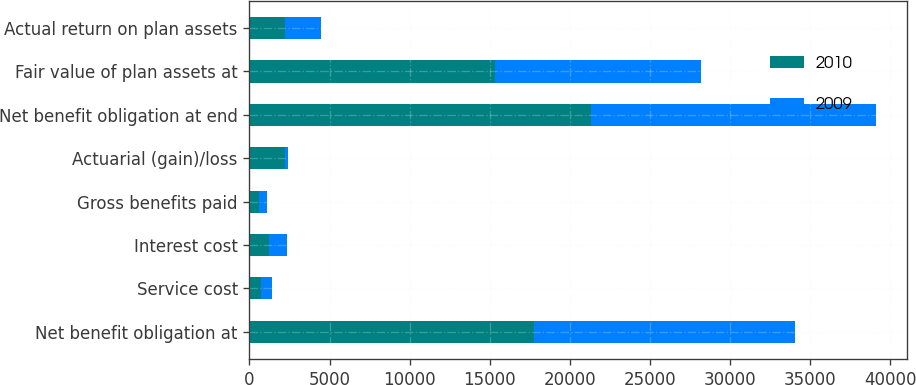<chart> <loc_0><loc_0><loc_500><loc_500><stacked_bar_chart><ecel><fcel>Net benefit obligation at<fcel>Service cost<fcel>Interest cost<fcel>Gross benefits paid<fcel>Actuarial (gain)/loss<fcel>Net benefit obligation at end<fcel>Fair value of plan assets at<fcel>Actual return on plan assets<nl><fcel>2010<fcel>17763<fcel>723<fcel>1199<fcel>574<fcel>2238<fcel>21342<fcel>15351<fcel>2215<nl><fcel>2009<fcel>16303<fcel>689<fcel>1130<fcel>504<fcel>141<fcel>17763<fcel>12809<fcel>2258<nl></chart> 